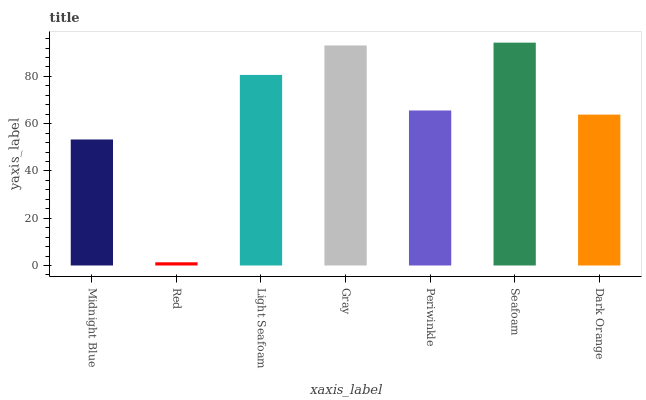Is Red the minimum?
Answer yes or no. Yes. Is Seafoam the maximum?
Answer yes or no. Yes. Is Light Seafoam the minimum?
Answer yes or no. No. Is Light Seafoam the maximum?
Answer yes or no. No. Is Light Seafoam greater than Red?
Answer yes or no. Yes. Is Red less than Light Seafoam?
Answer yes or no. Yes. Is Red greater than Light Seafoam?
Answer yes or no. No. Is Light Seafoam less than Red?
Answer yes or no. No. Is Periwinkle the high median?
Answer yes or no. Yes. Is Periwinkle the low median?
Answer yes or no. Yes. Is Gray the high median?
Answer yes or no. No. Is Midnight Blue the low median?
Answer yes or no. No. 